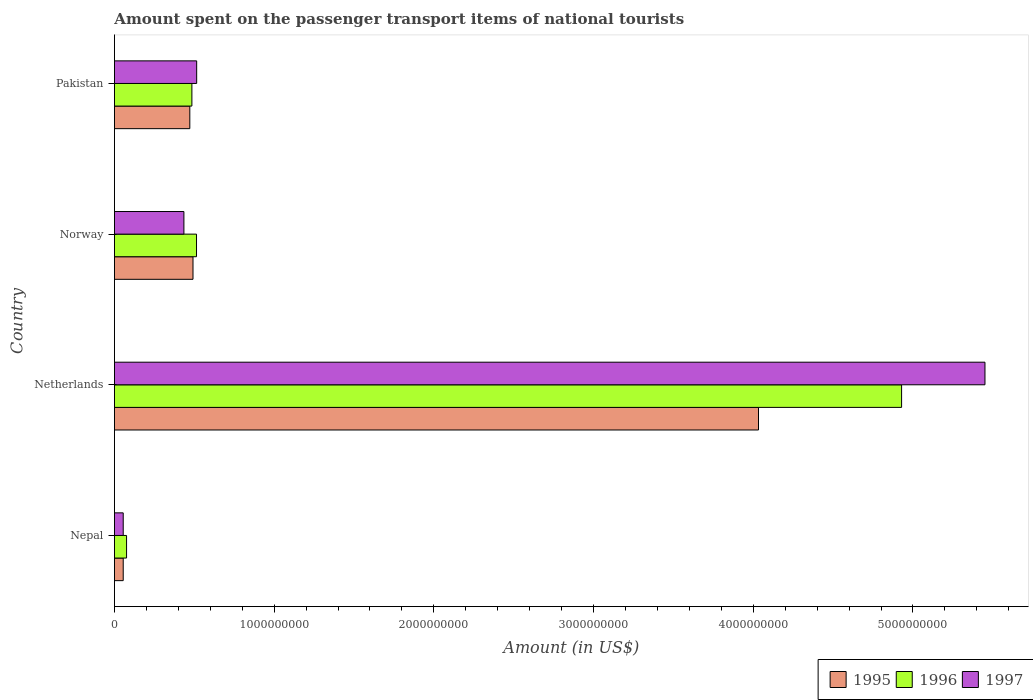How many different coloured bars are there?
Provide a succinct answer. 3. Are the number of bars per tick equal to the number of legend labels?
Make the answer very short. Yes. What is the label of the 2nd group of bars from the top?
Your response must be concise. Norway. In how many cases, is the number of bars for a given country not equal to the number of legend labels?
Your answer should be compact. 0. What is the amount spent on the passenger transport items of national tourists in 1997 in Norway?
Make the answer very short. 4.35e+08. Across all countries, what is the maximum amount spent on the passenger transport items of national tourists in 1995?
Offer a terse response. 4.03e+09. Across all countries, what is the minimum amount spent on the passenger transport items of national tourists in 1996?
Provide a succinct answer. 7.60e+07. In which country was the amount spent on the passenger transport items of national tourists in 1997 maximum?
Your response must be concise. Netherlands. In which country was the amount spent on the passenger transport items of national tourists in 1995 minimum?
Provide a succinct answer. Nepal. What is the total amount spent on the passenger transport items of national tourists in 1996 in the graph?
Give a very brief answer. 6.00e+09. What is the difference between the amount spent on the passenger transport items of national tourists in 1996 in Norway and that in Pakistan?
Give a very brief answer. 2.90e+07. What is the difference between the amount spent on the passenger transport items of national tourists in 1997 in Nepal and the amount spent on the passenger transport items of national tourists in 1995 in Norway?
Your answer should be compact. -4.37e+08. What is the average amount spent on the passenger transport items of national tourists in 1995 per country?
Provide a succinct answer. 1.26e+09. What is the difference between the amount spent on the passenger transport items of national tourists in 1995 and amount spent on the passenger transport items of national tourists in 1997 in Norway?
Provide a short and direct response. 5.70e+07. What is the ratio of the amount spent on the passenger transport items of national tourists in 1995 in Nepal to that in Netherlands?
Ensure brevity in your answer.  0.01. Is the difference between the amount spent on the passenger transport items of national tourists in 1995 in Norway and Pakistan greater than the difference between the amount spent on the passenger transport items of national tourists in 1997 in Norway and Pakistan?
Your answer should be compact. Yes. What is the difference between the highest and the second highest amount spent on the passenger transport items of national tourists in 1995?
Make the answer very short. 3.54e+09. What is the difference between the highest and the lowest amount spent on the passenger transport items of national tourists in 1996?
Provide a short and direct response. 4.85e+09. In how many countries, is the amount spent on the passenger transport items of national tourists in 1997 greater than the average amount spent on the passenger transport items of national tourists in 1997 taken over all countries?
Your answer should be compact. 1. What does the 2nd bar from the top in Netherlands represents?
Make the answer very short. 1996. How many bars are there?
Provide a short and direct response. 12. Are all the bars in the graph horizontal?
Provide a short and direct response. Yes. How many countries are there in the graph?
Keep it short and to the point. 4. What is the difference between two consecutive major ticks on the X-axis?
Keep it short and to the point. 1.00e+09. Where does the legend appear in the graph?
Your response must be concise. Bottom right. How are the legend labels stacked?
Make the answer very short. Horizontal. What is the title of the graph?
Keep it short and to the point. Amount spent on the passenger transport items of national tourists. What is the label or title of the X-axis?
Offer a terse response. Amount (in US$). What is the Amount (in US$) in 1995 in Nepal?
Offer a terse response. 5.50e+07. What is the Amount (in US$) in 1996 in Nepal?
Offer a terse response. 7.60e+07. What is the Amount (in US$) in 1997 in Nepal?
Keep it short and to the point. 5.50e+07. What is the Amount (in US$) in 1995 in Netherlands?
Your response must be concise. 4.03e+09. What is the Amount (in US$) of 1996 in Netherlands?
Ensure brevity in your answer.  4.93e+09. What is the Amount (in US$) in 1997 in Netherlands?
Give a very brief answer. 5.45e+09. What is the Amount (in US$) of 1995 in Norway?
Keep it short and to the point. 4.92e+08. What is the Amount (in US$) of 1996 in Norway?
Offer a terse response. 5.14e+08. What is the Amount (in US$) of 1997 in Norway?
Your answer should be compact. 4.35e+08. What is the Amount (in US$) of 1995 in Pakistan?
Your answer should be very brief. 4.72e+08. What is the Amount (in US$) in 1996 in Pakistan?
Make the answer very short. 4.85e+08. What is the Amount (in US$) in 1997 in Pakistan?
Make the answer very short. 5.15e+08. Across all countries, what is the maximum Amount (in US$) of 1995?
Your response must be concise. 4.03e+09. Across all countries, what is the maximum Amount (in US$) of 1996?
Make the answer very short. 4.93e+09. Across all countries, what is the maximum Amount (in US$) of 1997?
Your answer should be compact. 5.45e+09. Across all countries, what is the minimum Amount (in US$) in 1995?
Your answer should be very brief. 5.50e+07. Across all countries, what is the minimum Amount (in US$) in 1996?
Make the answer very short. 7.60e+07. Across all countries, what is the minimum Amount (in US$) in 1997?
Provide a succinct answer. 5.50e+07. What is the total Amount (in US$) of 1995 in the graph?
Offer a very short reply. 5.05e+09. What is the total Amount (in US$) of 1996 in the graph?
Ensure brevity in your answer.  6.00e+09. What is the total Amount (in US$) of 1997 in the graph?
Keep it short and to the point. 6.46e+09. What is the difference between the Amount (in US$) in 1995 in Nepal and that in Netherlands?
Your answer should be very brief. -3.98e+09. What is the difference between the Amount (in US$) of 1996 in Nepal and that in Netherlands?
Offer a terse response. -4.85e+09. What is the difference between the Amount (in US$) in 1997 in Nepal and that in Netherlands?
Provide a succinct answer. -5.40e+09. What is the difference between the Amount (in US$) of 1995 in Nepal and that in Norway?
Make the answer very short. -4.37e+08. What is the difference between the Amount (in US$) of 1996 in Nepal and that in Norway?
Give a very brief answer. -4.38e+08. What is the difference between the Amount (in US$) in 1997 in Nepal and that in Norway?
Provide a succinct answer. -3.80e+08. What is the difference between the Amount (in US$) of 1995 in Nepal and that in Pakistan?
Offer a very short reply. -4.17e+08. What is the difference between the Amount (in US$) of 1996 in Nepal and that in Pakistan?
Your answer should be very brief. -4.09e+08. What is the difference between the Amount (in US$) of 1997 in Nepal and that in Pakistan?
Your answer should be very brief. -4.60e+08. What is the difference between the Amount (in US$) in 1995 in Netherlands and that in Norway?
Provide a succinct answer. 3.54e+09. What is the difference between the Amount (in US$) in 1996 in Netherlands and that in Norway?
Your answer should be compact. 4.42e+09. What is the difference between the Amount (in US$) of 1997 in Netherlands and that in Norway?
Provide a succinct answer. 5.02e+09. What is the difference between the Amount (in US$) of 1995 in Netherlands and that in Pakistan?
Provide a short and direct response. 3.56e+09. What is the difference between the Amount (in US$) in 1996 in Netherlands and that in Pakistan?
Your answer should be compact. 4.44e+09. What is the difference between the Amount (in US$) in 1997 in Netherlands and that in Pakistan?
Ensure brevity in your answer.  4.94e+09. What is the difference between the Amount (in US$) in 1995 in Norway and that in Pakistan?
Your answer should be compact. 2.00e+07. What is the difference between the Amount (in US$) of 1996 in Norway and that in Pakistan?
Make the answer very short. 2.90e+07. What is the difference between the Amount (in US$) in 1997 in Norway and that in Pakistan?
Ensure brevity in your answer.  -8.00e+07. What is the difference between the Amount (in US$) of 1995 in Nepal and the Amount (in US$) of 1996 in Netherlands?
Keep it short and to the point. -4.87e+09. What is the difference between the Amount (in US$) in 1995 in Nepal and the Amount (in US$) in 1997 in Netherlands?
Provide a succinct answer. -5.40e+09. What is the difference between the Amount (in US$) in 1996 in Nepal and the Amount (in US$) in 1997 in Netherlands?
Make the answer very short. -5.38e+09. What is the difference between the Amount (in US$) of 1995 in Nepal and the Amount (in US$) of 1996 in Norway?
Your response must be concise. -4.59e+08. What is the difference between the Amount (in US$) in 1995 in Nepal and the Amount (in US$) in 1997 in Norway?
Provide a short and direct response. -3.80e+08. What is the difference between the Amount (in US$) in 1996 in Nepal and the Amount (in US$) in 1997 in Norway?
Your response must be concise. -3.59e+08. What is the difference between the Amount (in US$) in 1995 in Nepal and the Amount (in US$) in 1996 in Pakistan?
Make the answer very short. -4.30e+08. What is the difference between the Amount (in US$) of 1995 in Nepal and the Amount (in US$) of 1997 in Pakistan?
Make the answer very short. -4.60e+08. What is the difference between the Amount (in US$) in 1996 in Nepal and the Amount (in US$) in 1997 in Pakistan?
Keep it short and to the point. -4.39e+08. What is the difference between the Amount (in US$) in 1995 in Netherlands and the Amount (in US$) in 1996 in Norway?
Provide a short and direct response. 3.52e+09. What is the difference between the Amount (in US$) in 1995 in Netherlands and the Amount (in US$) in 1997 in Norway?
Offer a very short reply. 3.60e+09. What is the difference between the Amount (in US$) of 1996 in Netherlands and the Amount (in US$) of 1997 in Norway?
Your answer should be compact. 4.49e+09. What is the difference between the Amount (in US$) of 1995 in Netherlands and the Amount (in US$) of 1996 in Pakistan?
Provide a short and direct response. 3.55e+09. What is the difference between the Amount (in US$) of 1995 in Netherlands and the Amount (in US$) of 1997 in Pakistan?
Provide a succinct answer. 3.52e+09. What is the difference between the Amount (in US$) in 1996 in Netherlands and the Amount (in US$) in 1997 in Pakistan?
Provide a short and direct response. 4.41e+09. What is the difference between the Amount (in US$) of 1995 in Norway and the Amount (in US$) of 1997 in Pakistan?
Offer a terse response. -2.30e+07. What is the difference between the Amount (in US$) in 1996 in Norway and the Amount (in US$) in 1997 in Pakistan?
Your response must be concise. -1.00e+06. What is the average Amount (in US$) in 1995 per country?
Make the answer very short. 1.26e+09. What is the average Amount (in US$) in 1996 per country?
Ensure brevity in your answer.  1.50e+09. What is the average Amount (in US$) of 1997 per country?
Ensure brevity in your answer.  1.61e+09. What is the difference between the Amount (in US$) in 1995 and Amount (in US$) in 1996 in Nepal?
Your answer should be compact. -2.10e+07. What is the difference between the Amount (in US$) of 1995 and Amount (in US$) of 1997 in Nepal?
Make the answer very short. 0. What is the difference between the Amount (in US$) of 1996 and Amount (in US$) of 1997 in Nepal?
Keep it short and to the point. 2.10e+07. What is the difference between the Amount (in US$) in 1995 and Amount (in US$) in 1996 in Netherlands?
Ensure brevity in your answer.  -8.96e+08. What is the difference between the Amount (in US$) in 1995 and Amount (in US$) in 1997 in Netherlands?
Your answer should be compact. -1.42e+09. What is the difference between the Amount (in US$) of 1996 and Amount (in US$) of 1997 in Netherlands?
Keep it short and to the point. -5.22e+08. What is the difference between the Amount (in US$) in 1995 and Amount (in US$) in 1996 in Norway?
Your answer should be very brief. -2.20e+07. What is the difference between the Amount (in US$) of 1995 and Amount (in US$) of 1997 in Norway?
Your answer should be compact. 5.70e+07. What is the difference between the Amount (in US$) in 1996 and Amount (in US$) in 1997 in Norway?
Your answer should be compact. 7.90e+07. What is the difference between the Amount (in US$) of 1995 and Amount (in US$) of 1996 in Pakistan?
Make the answer very short. -1.30e+07. What is the difference between the Amount (in US$) of 1995 and Amount (in US$) of 1997 in Pakistan?
Provide a succinct answer. -4.30e+07. What is the difference between the Amount (in US$) of 1996 and Amount (in US$) of 1997 in Pakistan?
Provide a short and direct response. -3.00e+07. What is the ratio of the Amount (in US$) in 1995 in Nepal to that in Netherlands?
Your answer should be very brief. 0.01. What is the ratio of the Amount (in US$) of 1996 in Nepal to that in Netherlands?
Offer a terse response. 0.02. What is the ratio of the Amount (in US$) in 1997 in Nepal to that in Netherlands?
Ensure brevity in your answer.  0.01. What is the ratio of the Amount (in US$) in 1995 in Nepal to that in Norway?
Provide a short and direct response. 0.11. What is the ratio of the Amount (in US$) in 1996 in Nepal to that in Norway?
Your answer should be compact. 0.15. What is the ratio of the Amount (in US$) in 1997 in Nepal to that in Norway?
Your response must be concise. 0.13. What is the ratio of the Amount (in US$) of 1995 in Nepal to that in Pakistan?
Provide a succinct answer. 0.12. What is the ratio of the Amount (in US$) of 1996 in Nepal to that in Pakistan?
Offer a very short reply. 0.16. What is the ratio of the Amount (in US$) of 1997 in Nepal to that in Pakistan?
Provide a succinct answer. 0.11. What is the ratio of the Amount (in US$) of 1995 in Netherlands to that in Norway?
Make the answer very short. 8.2. What is the ratio of the Amount (in US$) in 1996 in Netherlands to that in Norway?
Your answer should be very brief. 9.59. What is the ratio of the Amount (in US$) in 1997 in Netherlands to that in Norway?
Offer a terse response. 12.53. What is the ratio of the Amount (in US$) of 1995 in Netherlands to that in Pakistan?
Provide a succinct answer. 8.54. What is the ratio of the Amount (in US$) in 1996 in Netherlands to that in Pakistan?
Your response must be concise. 10.16. What is the ratio of the Amount (in US$) of 1997 in Netherlands to that in Pakistan?
Your answer should be very brief. 10.58. What is the ratio of the Amount (in US$) in 1995 in Norway to that in Pakistan?
Make the answer very short. 1.04. What is the ratio of the Amount (in US$) of 1996 in Norway to that in Pakistan?
Provide a succinct answer. 1.06. What is the ratio of the Amount (in US$) of 1997 in Norway to that in Pakistan?
Offer a very short reply. 0.84. What is the difference between the highest and the second highest Amount (in US$) in 1995?
Make the answer very short. 3.54e+09. What is the difference between the highest and the second highest Amount (in US$) in 1996?
Keep it short and to the point. 4.42e+09. What is the difference between the highest and the second highest Amount (in US$) of 1997?
Ensure brevity in your answer.  4.94e+09. What is the difference between the highest and the lowest Amount (in US$) in 1995?
Your response must be concise. 3.98e+09. What is the difference between the highest and the lowest Amount (in US$) in 1996?
Your answer should be compact. 4.85e+09. What is the difference between the highest and the lowest Amount (in US$) in 1997?
Offer a very short reply. 5.40e+09. 